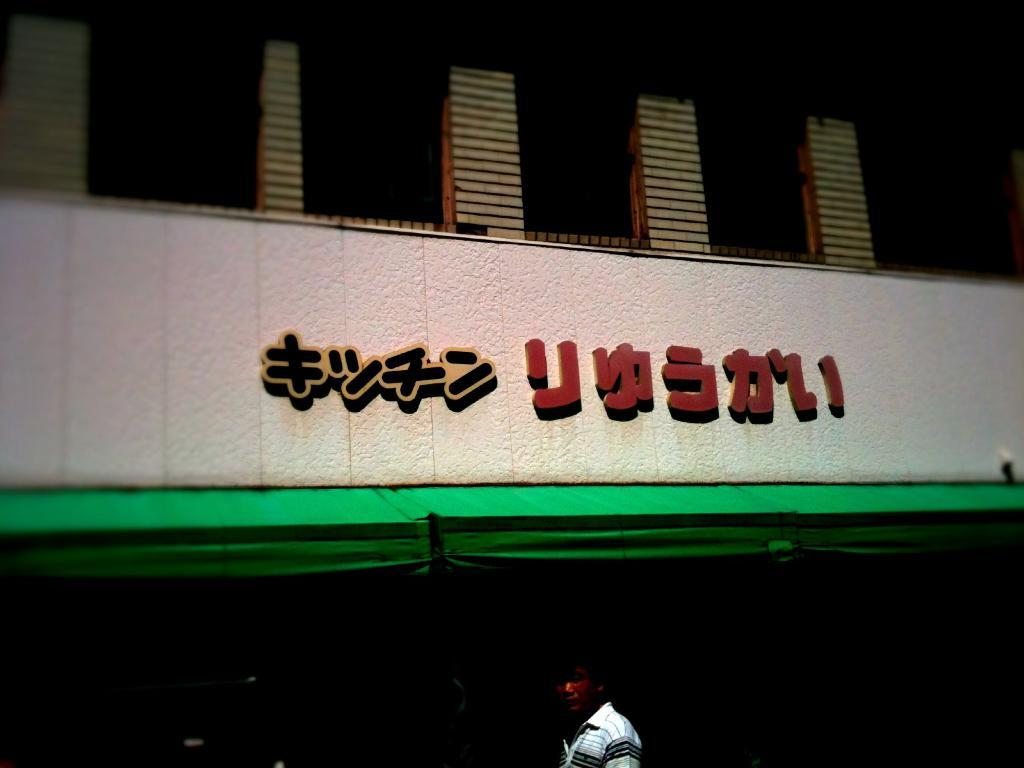What is the main subject of the image? There is a person standing in the image. Where is the person located in the image? The person is at the bottom of the image. What can be seen in the background of the image? There is a building and text on a wall in the background of the image. What type of crack is visible on the person's skin in the image? There is no crack visible on the person's skin in the image. Can you tell me how many beetles are crawling on the person's arm in the image? There are no beetles present in the image. 